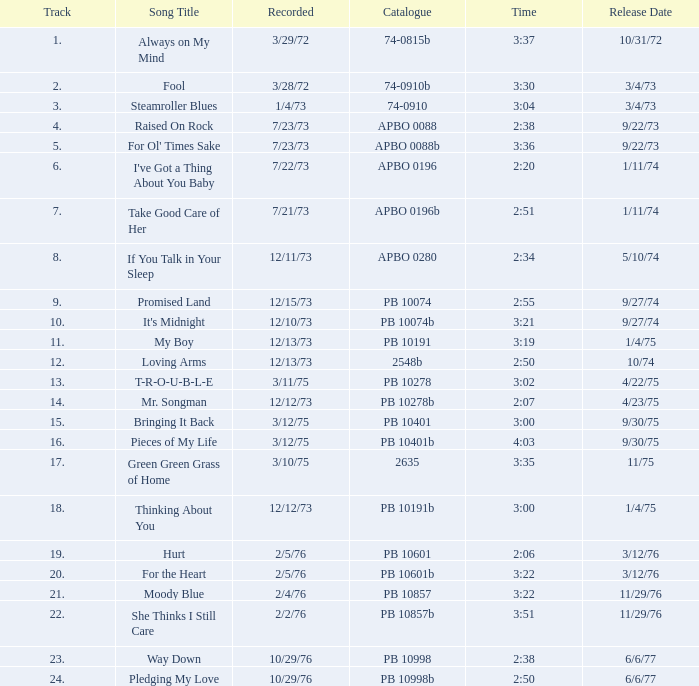Tell me the release date record on 10/29/76 and a time on 2:50 6/6/77. 